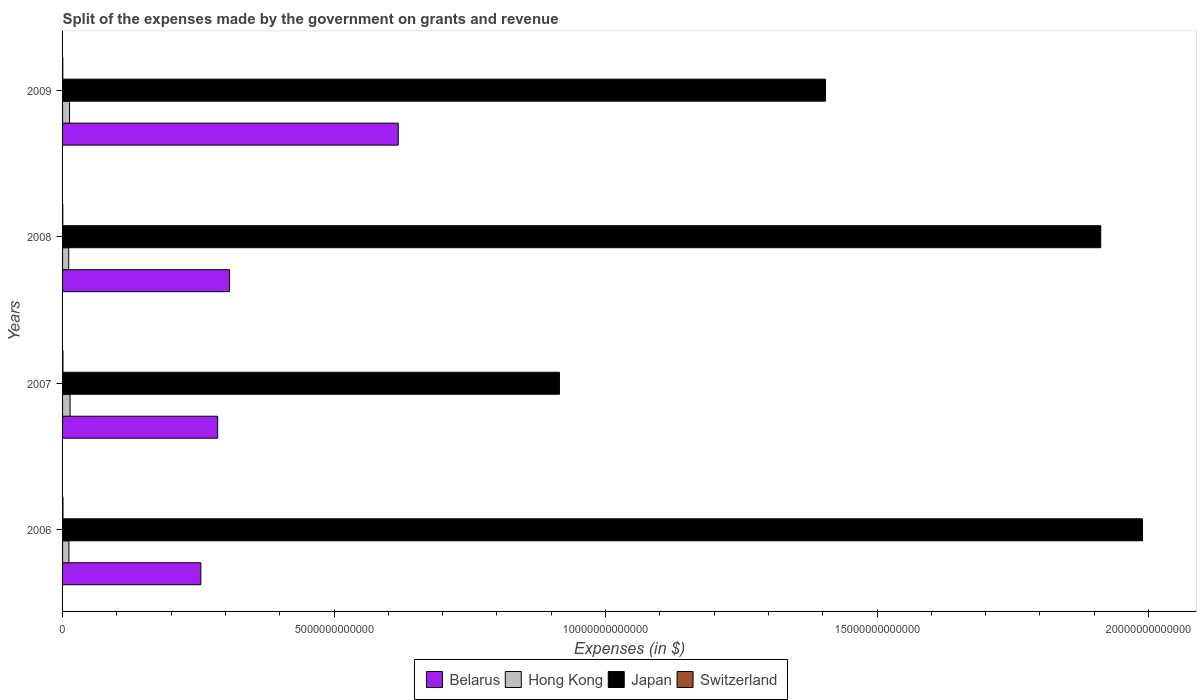Are the number of bars on each tick of the Y-axis equal?
Provide a succinct answer. Yes. How many bars are there on the 2nd tick from the top?
Ensure brevity in your answer.  4. What is the label of the 1st group of bars from the top?
Provide a short and direct response. 2009. In how many cases, is the number of bars for a given year not equal to the number of legend labels?
Offer a terse response. 0. What is the expenses made by the government on grants and revenue in Belarus in 2007?
Keep it short and to the point. 2.86e+12. Across all years, what is the maximum expenses made by the government on grants and revenue in Japan?
Offer a terse response. 1.99e+13. Across all years, what is the minimum expenses made by the government on grants and revenue in Japan?
Provide a succinct answer. 9.15e+12. In which year was the expenses made by the government on grants and revenue in Hong Kong minimum?
Give a very brief answer. 2008. What is the total expenses made by the government on grants and revenue in Japan in the graph?
Provide a short and direct response. 6.22e+13. What is the difference between the expenses made by the government on grants and revenue in Belarus in 2007 and that in 2008?
Offer a very short reply. -2.19e+11. What is the difference between the expenses made by the government on grants and revenue in Hong Kong in 2006 and the expenses made by the government on grants and revenue in Belarus in 2009?
Make the answer very short. -6.06e+12. What is the average expenses made by the government on grants and revenue in Belarus per year?
Give a very brief answer. 3.66e+12. In the year 2009, what is the difference between the expenses made by the government on grants and revenue in Switzerland and expenses made by the government on grants and revenue in Japan?
Keep it short and to the point. -1.40e+13. In how many years, is the expenses made by the government on grants and revenue in Japan greater than 10000000000000 $?
Keep it short and to the point. 3. What is the ratio of the expenses made by the government on grants and revenue in Hong Kong in 2008 to that in 2009?
Your response must be concise. 0.88. What is the difference between the highest and the second highest expenses made by the government on grants and revenue in Switzerland?
Ensure brevity in your answer.  5.80e+08. What is the difference between the highest and the lowest expenses made by the government on grants and revenue in Switzerland?
Your response must be concise. 3.45e+09. In how many years, is the expenses made by the government on grants and revenue in Hong Kong greater than the average expenses made by the government on grants and revenue in Hong Kong taken over all years?
Make the answer very short. 2. Is the sum of the expenses made by the government on grants and revenue in Switzerland in 2008 and 2009 greater than the maximum expenses made by the government on grants and revenue in Hong Kong across all years?
Your answer should be compact. No. Is it the case that in every year, the sum of the expenses made by the government on grants and revenue in Hong Kong and expenses made by the government on grants and revenue in Belarus is greater than the sum of expenses made by the government on grants and revenue in Japan and expenses made by the government on grants and revenue in Switzerland?
Provide a succinct answer. No. What does the 4th bar from the top in 2008 represents?
Provide a short and direct response. Belarus. What does the 1st bar from the bottom in 2009 represents?
Offer a very short reply. Belarus. Is it the case that in every year, the sum of the expenses made by the government on grants and revenue in Hong Kong and expenses made by the government on grants and revenue in Switzerland is greater than the expenses made by the government on grants and revenue in Japan?
Your answer should be very brief. No. How many bars are there?
Offer a terse response. 16. How many years are there in the graph?
Offer a terse response. 4. What is the difference between two consecutive major ticks on the X-axis?
Your answer should be very brief. 5.00e+12. Does the graph contain any zero values?
Offer a very short reply. No. How many legend labels are there?
Offer a very short reply. 4. How are the legend labels stacked?
Keep it short and to the point. Horizontal. What is the title of the graph?
Make the answer very short. Split of the expenses made by the government on grants and revenue. Does "Low income" appear as one of the legend labels in the graph?
Your response must be concise. No. What is the label or title of the X-axis?
Your response must be concise. Expenses (in $). What is the label or title of the Y-axis?
Ensure brevity in your answer.  Years. What is the Expenses (in $) of Belarus in 2006?
Keep it short and to the point. 2.55e+12. What is the Expenses (in $) of Hong Kong in 2006?
Provide a short and direct response. 1.18e+11. What is the Expenses (in $) in Japan in 2006?
Keep it short and to the point. 1.99e+13. What is the Expenses (in $) of Switzerland in 2006?
Give a very brief answer. 7.36e+09. What is the Expenses (in $) of Belarus in 2007?
Provide a succinct answer. 2.86e+12. What is the Expenses (in $) in Hong Kong in 2007?
Provide a succinct answer. 1.38e+11. What is the Expenses (in $) of Japan in 2007?
Provide a succinct answer. 9.15e+12. What is the Expenses (in $) of Switzerland in 2007?
Offer a terse response. 6.78e+09. What is the Expenses (in $) in Belarus in 2008?
Your answer should be compact. 3.08e+12. What is the Expenses (in $) in Hong Kong in 2008?
Make the answer very short. 1.13e+11. What is the Expenses (in $) in Japan in 2008?
Provide a succinct answer. 1.91e+13. What is the Expenses (in $) in Switzerland in 2008?
Your response must be concise. 4.28e+09. What is the Expenses (in $) in Belarus in 2009?
Your answer should be very brief. 6.18e+12. What is the Expenses (in $) in Hong Kong in 2009?
Your response must be concise. 1.28e+11. What is the Expenses (in $) in Japan in 2009?
Give a very brief answer. 1.41e+13. What is the Expenses (in $) of Switzerland in 2009?
Provide a short and direct response. 3.91e+09. Across all years, what is the maximum Expenses (in $) of Belarus?
Give a very brief answer. 6.18e+12. Across all years, what is the maximum Expenses (in $) of Hong Kong?
Offer a terse response. 1.38e+11. Across all years, what is the maximum Expenses (in $) of Japan?
Ensure brevity in your answer.  1.99e+13. Across all years, what is the maximum Expenses (in $) in Switzerland?
Ensure brevity in your answer.  7.36e+09. Across all years, what is the minimum Expenses (in $) of Belarus?
Keep it short and to the point. 2.55e+12. Across all years, what is the minimum Expenses (in $) in Hong Kong?
Your answer should be very brief. 1.13e+11. Across all years, what is the minimum Expenses (in $) in Japan?
Ensure brevity in your answer.  9.15e+12. Across all years, what is the minimum Expenses (in $) in Switzerland?
Offer a very short reply. 3.91e+09. What is the total Expenses (in $) in Belarus in the graph?
Make the answer very short. 1.47e+13. What is the total Expenses (in $) in Hong Kong in the graph?
Ensure brevity in your answer.  4.97e+11. What is the total Expenses (in $) of Japan in the graph?
Make the answer very short. 6.22e+13. What is the total Expenses (in $) of Switzerland in the graph?
Ensure brevity in your answer.  2.23e+1. What is the difference between the Expenses (in $) in Belarus in 2006 and that in 2007?
Your response must be concise. -3.10e+11. What is the difference between the Expenses (in $) of Hong Kong in 2006 and that in 2007?
Offer a terse response. -2.05e+1. What is the difference between the Expenses (in $) in Japan in 2006 and that in 2007?
Offer a terse response. 1.07e+13. What is the difference between the Expenses (in $) in Switzerland in 2006 and that in 2007?
Your answer should be compact. 5.80e+08. What is the difference between the Expenses (in $) of Belarus in 2006 and that in 2008?
Provide a succinct answer. -5.29e+11. What is the difference between the Expenses (in $) of Hong Kong in 2006 and that in 2008?
Offer a terse response. 4.56e+09. What is the difference between the Expenses (in $) in Japan in 2006 and that in 2008?
Keep it short and to the point. 7.69e+11. What is the difference between the Expenses (in $) of Switzerland in 2006 and that in 2008?
Offer a very short reply. 3.08e+09. What is the difference between the Expenses (in $) in Belarus in 2006 and that in 2009?
Your answer should be very brief. -3.64e+12. What is the difference between the Expenses (in $) in Hong Kong in 2006 and that in 2009?
Your answer should be very brief. -1.07e+1. What is the difference between the Expenses (in $) in Japan in 2006 and that in 2009?
Provide a succinct answer. 5.84e+12. What is the difference between the Expenses (in $) in Switzerland in 2006 and that in 2009?
Your answer should be very brief. 3.45e+09. What is the difference between the Expenses (in $) of Belarus in 2007 and that in 2008?
Ensure brevity in your answer.  -2.19e+11. What is the difference between the Expenses (in $) of Hong Kong in 2007 and that in 2008?
Make the answer very short. 2.50e+1. What is the difference between the Expenses (in $) of Japan in 2007 and that in 2008?
Provide a short and direct response. -9.97e+12. What is the difference between the Expenses (in $) in Switzerland in 2007 and that in 2008?
Keep it short and to the point. 2.50e+09. What is the difference between the Expenses (in $) in Belarus in 2007 and that in 2009?
Provide a succinct answer. -3.33e+12. What is the difference between the Expenses (in $) of Hong Kong in 2007 and that in 2009?
Offer a very short reply. 9.71e+09. What is the difference between the Expenses (in $) of Japan in 2007 and that in 2009?
Your answer should be compact. -4.90e+12. What is the difference between the Expenses (in $) in Switzerland in 2007 and that in 2009?
Your response must be concise. 2.87e+09. What is the difference between the Expenses (in $) of Belarus in 2008 and that in 2009?
Give a very brief answer. -3.11e+12. What is the difference between the Expenses (in $) of Hong Kong in 2008 and that in 2009?
Your answer should be very brief. -1.53e+1. What is the difference between the Expenses (in $) of Japan in 2008 and that in 2009?
Offer a terse response. 5.07e+12. What is the difference between the Expenses (in $) of Switzerland in 2008 and that in 2009?
Offer a very short reply. 3.68e+08. What is the difference between the Expenses (in $) in Belarus in 2006 and the Expenses (in $) in Hong Kong in 2007?
Give a very brief answer. 2.41e+12. What is the difference between the Expenses (in $) in Belarus in 2006 and the Expenses (in $) in Japan in 2007?
Ensure brevity in your answer.  -6.61e+12. What is the difference between the Expenses (in $) in Belarus in 2006 and the Expenses (in $) in Switzerland in 2007?
Your answer should be compact. 2.54e+12. What is the difference between the Expenses (in $) of Hong Kong in 2006 and the Expenses (in $) of Japan in 2007?
Your answer should be compact. -9.03e+12. What is the difference between the Expenses (in $) in Hong Kong in 2006 and the Expenses (in $) in Switzerland in 2007?
Offer a very short reply. 1.11e+11. What is the difference between the Expenses (in $) in Japan in 2006 and the Expenses (in $) in Switzerland in 2007?
Your response must be concise. 1.99e+13. What is the difference between the Expenses (in $) in Belarus in 2006 and the Expenses (in $) in Hong Kong in 2008?
Your answer should be compact. 2.43e+12. What is the difference between the Expenses (in $) of Belarus in 2006 and the Expenses (in $) of Japan in 2008?
Make the answer very short. -1.66e+13. What is the difference between the Expenses (in $) in Belarus in 2006 and the Expenses (in $) in Switzerland in 2008?
Make the answer very short. 2.54e+12. What is the difference between the Expenses (in $) in Hong Kong in 2006 and the Expenses (in $) in Japan in 2008?
Your answer should be compact. -1.90e+13. What is the difference between the Expenses (in $) of Hong Kong in 2006 and the Expenses (in $) of Switzerland in 2008?
Your answer should be very brief. 1.13e+11. What is the difference between the Expenses (in $) in Japan in 2006 and the Expenses (in $) in Switzerland in 2008?
Provide a succinct answer. 1.99e+13. What is the difference between the Expenses (in $) of Belarus in 2006 and the Expenses (in $) of Hong Kong in 2009?
Your response must be concise. 2.42e+12. What is the difference between the Expenses (in $) in Belarus in 2006 and the Expenses (in $) in Japan in 2009?
Keep it short and to the point. -1.15e+13. What is the difference between the Expenses (in $) in Belarus in 2006 and the Expenses (in $) in Switzerland in 2009?
Offer a terse response. 2.54e+12. What is the difference between the Expenses (in $) of Hong Kong in 2006 and the Expenses (in $) of Japan in 2009?
Keep it short and to the point. -1.39e+13. What is the difference between the Expenses (in $) in Hong Kong in 2006 and the Expenses (in $) in Switzerland in 2009?
Offer a terse response. 1.14e+11. What is the difference between the Expenses (in $) in Japan in 2006 and the Expenses (in $) in Switzerland in 2009?
Ensure brevity in your answer.  1.99e+13. What is the difference between the Expenses (in $) in Belarus in 2007 and the Expenses (in $) in Hong Kong in 2008?
Offer a very short reply. 2.74e+12. What is the difference between the Expenses (in $) in Belarus in 2007 and the Expenses (in $) in Japan in 2008?
Offer a very short reply. -1.63e+13. What is the difference between the Expenses (in $) of Belarus in 2007 and the Expenses (in $) of Switzerland in 2008?
Ensure brevity in your answer.  2.85e+12. What is the difference between the Expenses (in $) of Hong Kong in 2007 and the Expenses (in $) of Japan in 2008?
Provide a short and direct response. -1.90e+13. What is the difference between the Expenses (in $) of Hong Kong in 2007 and the Expenses (in $) of Switzerland in 2008?
Offer a terse response. 1.34e+11. What is the difference between the Expenses (in $) of Japan in 2007 and the Expenses (in $) of Switzerland in 2008?
Provide a succinct answer. 9.15e+12. What is the difference between the Expenses (in $) in Belarus in 2007 and the Expenses (in $) in Hong Kong in 2009?
Give a very brief answer. 2.73e+12. What is the difference between the Expenses (in $) of Belarus in 2007 and the Expenses (in $) of Japan in 2009?
Offer a terse response. -1.12e+13. What is the difference between the Expenses (in $) of Belarus in 2007 and the Expenses (in $) of Switzerland in 2009?
Offer a terse response. 2.85e+12. What is the difference between the Expenses (in $) in Hong Kong in 2007 and the Expenses (in $) in Japan in 2009?
Offer a terse response. -1.39e+13. What is the difference between the Expenses (in $) in Hong Kong in 2007 and the Expenses (in $) in Switzerland in 2009?
Provide a short and direct response. 1.34e+11. What is the difference between the Expenses (in $) in Japan in 2007 and the Expenses (in $) in Switzerland in 2009?
Your answer should be compact. 9.15e+12. What is the difference between the Expenses (in $) of Belarus in 2008 and the Expenses (in $) of Hong Kong in 2009?
Ensure brevity in your answer.  2.95e+12. What is the difference between the Expenses (in $) in Belarus in 2008 and the Expenses (in $) in Japan in 2009?
Your answer should be compact. -1.10e+13. What is the difference between the Expenses (in $) of Belarus in 2008 and the Expenses (in $) of Switzerland in 2009?
Your answer should be compact. 3.07e+12. What is the difference between the Expenses (in $) of Hong Kong in 2008 and the Expenses (in $) of Japan in 2009?
Your answer should be compact. -1.39e+13. What is the difference between the Expenses (in $) of Hong Kong in 2008 and the Expenses (in $) of Switzerland in 2009?
Give a very brief answer. 1.09e+11. What is the difference between the Expenses (in $) of Japan in 2008 and the Expenses (in $) of Switzerland in 2009?
Keep it short and to the point. 1.91e+13. What is the average Expenses (in $) of Belarus per year?
Your answer should be compact. 3.66e+12. What is the average Expenses (in $) of Hong Kong per year?
Give a very brief answer. 1.24e+11. What is the average Expenses (in $) of Japan per year?
Your answer should be very brief. 1.56e+13. What is the average Expenses (in $) in Switzerland per year?
Your answer should be very brief. 5.58e+09. In the year 2006, what is the difference between the Expenses (in $) of Belarus and Expenses (in $) of Hong Kong?
Your response must be concise. 2.43e+12. In the year 2006, what is the difference between the Expenses (in $) in Belarus and Expenses (in $) in Japan?
Keep it short and to the point. -1.73e+13. In the year 2006, what is the difference between the Expenses (in $) of Belarus and Expenses (in $) of Switzerland?
Offer a very short reply. 2.54e+12. In the year 2006, what is the difference between the Expenses (in $) in Hong Kong and Expenses (in $) in Japan?
Your answer should be very brief. -1.98e+13. In the year 2006, what is the difference between the Expenses (in $) of Hong Kong and Expenses (in $) of Switzerland?
Your answer should be very brief. 1.10e+11. In the year 2006, what is the difference between the Expenses (in $) of Japan and Expenses (in $) of Switzerland?
Offer a very short reply. 1.99e+13. In the year 2007, what is the difference between the Expenses (in $) of Belarus and Expenses (in $) of Hong Kong?
Your answer should be compact. 2.72e+12. In the year 2007, what is the difference between the Expenses (in $) of Belarus and Expenses (in $) of Japan?
Provide a short and direct response. -6.29e+12. In the year 2007, what is the difference between the Expenses (in $) in Belarus and Expenses (in $) in Switzerland?
Ensure brevity in your answer.  2.85e+12. In the year 2007, what is the difference between the Expenses (in $) of Hong Kong and Expenses (in $) of Japan?
Your answer should be compact. -9.01e+12. In the year 2007, what is the difference between the Expenses (in $) in Hong Kong and Expenses (in $) in Switzerland?
Make the answer very short. 1.31e+11. In the year 2007, what is the difference between the Expenses (in $) of Japan and Expenses (in $) of Switzerland?
Offer a terse response. 9.14e+12. In the year 2008, what is the difference between the Expenses (in $) of Belarus and Expenses (in $) of Hong Kong?
Offer a terse response. 2.96e+12. In the year 2008, what is the difference between the Expenses (in $) in Belarus and Expenses (in $) in Japan?
Provide a succinct answer. -1.60e+13. In the year 2008, what is the difference between the Expenses (in $) of Belarus and Expenses (in $) of Switzerland?
Your response must be concise. 3.07e+12. In the year 2008, what is the difference between the Expenses (in $) of Hong Kong and Expenses (in $) of Japan?
Make the answer very short. -1.90e+13. In the year 2008, what is the difference between the Expenses (in $) of Hong Kong and Expenses (in $) of Switzerland?
Your answer should be very brief. 1.09e+11. In the year 2008, what is the difference between the Expenses (in $) of Japan and Expenses (in $) of Switzerland?
Your answer should be compact. 1.91e+13. In the year 2009, what is the difference between the Expenses (in $) in Belarus and Expenses (in $) in Hong Kong?
Your answer should be very brief. 6.05e+12. In the year 2009, what is the difference between the Expenses (in $) of Belarus and Expenses (in $) of Japan?
Your answer should be compact. -7.87e+12. In the year 2009, what is the difference between the Expenses (in $) of Belarus and Expenses (in $) of Switzerland?
Offer a terse response. 6.18e+12. In the year 2009, what is the difference between the Expenses (in $) in Hong Kong and Expenses (in $) in Japan?
Your answer should be compact. -1.39e+13. In the year 2009, what is the difference between the Expenses (in $) in Hong Kong and Expenses (in $) in Switzerland?
Your answer should be compact. 1.24e+11. In the year 2009, what is the difference between the Expenses (in $) of Japan and Expenses (in $) of Switzerland?
Offer a terse response. 1.40e+13. What is the ratio of the Expenses (in $) in Belarus in 2006 to that in 2007?
Give a very brief answer. 0.89. What is the ratio of the Expenses (in $) of Hong Kong in 2006 to that in 2007?
Make the answer very short. 0.85. What is the ratio of the Expenses (in $) of Japan in 2006 to that in 2007?
Give a very brief answer. 2.17. What is the ratio of the Expenses (in $) of Switzerland in 2006 to that in 2007?
Offer a terse response. 1.09. What is the ratio of the Expenses (in $) of Belarus in 2006 to that in 2008?
Make the answer very short. 0.83. What is the ratio of the Expenses (in $) of Hong Kong in 2006 to that in 2008?
Your response must be concise. 1.04. What is the ratio of the Expenses (in $) in Japan in 2006 to that in 2008?
Provide a short and direct response. 1.04. What is the ratio of the Expenses (in $) of Switzerland in 2006 to that in 2008?
Keep it short and to the point. 1.72. What is the ratio of the Expenses (in $) in Belarus in 2006 to that in 2009?
Provide a succinct answer. 0.41. What is the ratio of the Expenses (in $) in Hong Kong in 2006 to that in 2009?
Your answer should be compact. 0.92. What is the ratio of the Expenses (in $) of Japan in 2006 to that in 2009?
Make the answer very short. 1.42. What is the ratio of the Expenses (in $) in Switzerland in 2006 to that in 2009?
Ensure brevity in your answer.  1.88. What is the ratio of the Expenses (in $) in Belarus in 2007 to that in 2008?
Offer a very short reply. 0.93. What is the ratio of the Expenses (in $) of Hong Kong in 2007 to that in 2008?
Offer a very short reply. 1.22. What is the ratio of the Expenses (in $) in Japan in 2007 to that in 2008?
Provide a succinct answer. 0.48. What is the ratio of the Expenses (in $) of Switzerland in 2007 to that in 2008?
Make the answer very short. 1.58. What is the ratio of the Expenses (in $) of Belarus in 2007 to that in 2009?
Offer a very short reply. 0.46. What is the ratio of the Expenses (in $) in Hong Kong in 2007 to that in 2009?
Offer a terse response. 1.08. What is the ratio of the Expenses (in $) in Japan in 2007 to that in 2009?
Give a very brief answer. 0.65. What is the ratio of the Expenses (in $) of Switzerland in 2007 to that in 2009?
Your answer should be very brief. 1.73. What is the ratio of the Expenses (in $) in Belarus in 2008 to that in 2009?
Provide a short and direct response. 0.5. What is the ratio of the Expenses (in $) in Hong Kong in 2008 to that in 2009?
Your answer should be compact. 0.88. What is the ratio of the Expenses (in $) in Japan in 2008 to that in 2009?
Your response must be concise. 1.36. What is the ratio of the Expenses (in $) of Switzerland in 2008 to that in 2009?
Your answer should be compact. 1.09. What is the difference between the highest and the second highest Expenses (in $) of Belarus?
Offer a terse response. 3.11e+12. What is the difference between the highest and the second highest Expenses (in $) of Hong Kong?
Keep it short and to the point. 9.71e+09. What is the difference between the highest and the second highest Expenses (in $) in Japan?
Keep it short and to the point. 7.69e+11. What is the difference between the highest and the second highest Expenses (in $) in Switzerland?
Provide a succinct answer. 5.80e+08. What is the difference between the highest and the lowest Expenses (in $) of Belarus?
Ensure brevity in your answer.  3.64e+12. What is the difference between the highest and the lowest Expenses (in $) of Hong Kong?
Ensure brevity in your answer.  2.50e+1. What is the difference between the highest and the lowest Expenses (in $) of Japan?
Your response must be concise. 1.07e+13. What is the difference between the highest and the lowest Expenses (in $) of Switzerland?
Your answer should be very brief. 3.45e+09. 